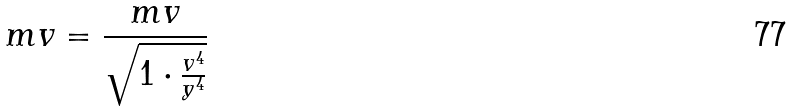<formula> <loc_0><loc_0><loc_500><loc_500>m v = \frac { m v } { \sqrt { 1 \cdot \frac { v ^ { 4 } } { y ^ { 4 } } } }</formula> 